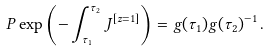Convert formula to latex. <formula><loc_0><loc_0><loc_500><loc_500>P \exp \left ( - \int _ { \tau _ { 1 } } ^ { \tau _ { 2 } } J ^ { [ z = 1 ] } \right ) = g ( \tau _ { 1 } ) g ( \tau _ { 2 } ) ^ { - 1 } \, .</formula> 